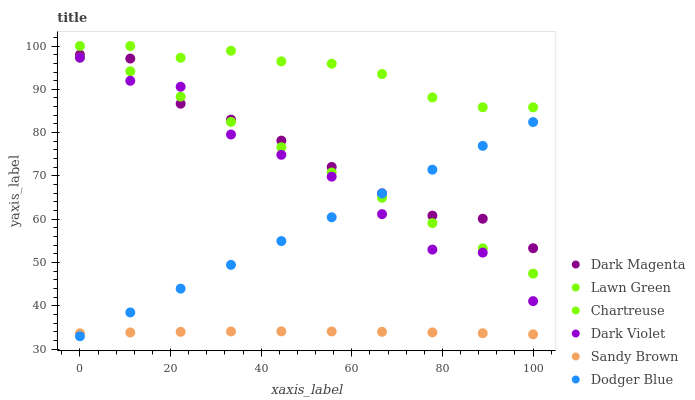Does Sandy Brown have the minimum area under the curve?
Answer yes or no. Yes. Does Chartreuse have the maximum area under the curve?
Answer yes or no. Yes. Does Dark Magenta have the minimum area under the curve?
Answer yes or no. No. Does Dark Magenta have the maximum area under the curve?
Answer yes or no. No. Is Lawn Green the smoothest?
Answer yes or no. Yes. Is Dark Violet the roughest?
Answer yes or no. Yes. Is Dark Magenta the smoothest?
Answer yes or no. No. Is Dark Magenta the roughest?
Answer yes or no. No. Does Dodger Blue have the lowest value?
Answer yes or no. Yes. Does Dark Magenta have the lowest value?
Answer yes or no. No. Does Chartreuse have the highest value?
Answer yes or no. Yes. Does Dark Magenta have the highest value?
Answer yes or no. No. Is Dodger Blue less than Chartreuse?
Answer yes or no. Yes. Is Dark Violet greater than Sandy Brown?
Answer yes or no. Yes. Does Dodger Blue intersect Lawn Green?
Answer yes or no. Yes. Is Dodger Blue less than Lawn Green?
Answer yes or no. No. Is Dodger Blue greater than Lawn Green?
Answer yes or no. No. Does Dodger Blue intersect Chartreuse?
Answer yes or no. No. 